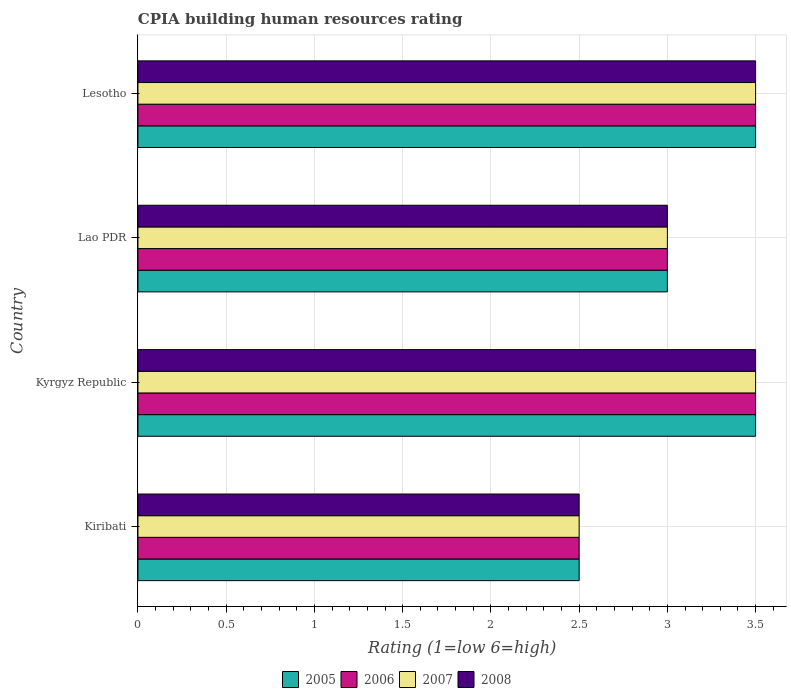How many different coloured bars are there?
Provide a succinct answer. 4. How many groups of bars are there?
Your answer should be very brief. 4. Are the number of bars on each tick of the Y-axis equal?
Your response must be concise. Yes. What is the label of the 3rd group of bars from the top?
Offer a terse response. Kyrgyz Republic. What is the CPIA rating in 2005 in Lesotho?
Your answer should be compact. 3.5. Across all countries, what is the minimum CPIA rating in 2005?
Provide a succinct answer. 2.5. In which country was the CPIA rating in 2008 maximum?
Provide a short and direct response. Kyrgyz Republic. In which country was the CPIA rating in 2005 minimum?
Your answer should be compact. Kiribati. What is the total CPIA rating in 2005 in the graph?
Your response must be concise. 12.5. What is the average CPIA rating in 2008 per country?
Ensure brevity in your answer.  3.12. What is the difference between the CPIA rating in 2008 and CPIA rating in 2006 in Lao PDR?
Your response must be concise. 0. In how many countries, is the CPIA rating in 2007 greater than 2.3 ?
Your response must be concise. 4. What is the ratio of the CPIA rating in 2008 in Kiribati to that in Lao PDR?
Offer a terse response. 0.83. Is the CPIA rating in 2006 in Lao PDR less than that in Lesotho?
Give a very brief answer. Yes. What is the difference between the highest and the second highest CPIA rating in 2005?
Your answer should be compact. 0. Is the sum of the CPIA rating in 2007 in Lao PDR and Lesotho greater than the maximum CPIA rating in 2008 across all countries?
Make the answer very short. Yes. What does the 4th bar from the top in Kiribati represents?
Offer a very short reply. 2005. What does the 2nd bar from the bottom in Lao PDR represents?
Provide a succinct answer. 2006. Is it the case that in every country, the sum of the CPIA rating in 2007 and CPIA rating in 2008 is greater than the CPIA rating in 2005?
Give a very brief answer. Yes. How many bars are there?
Provide a short and direct response. 16. Are all the bars in the graph horizontal?
Your answer should be compact. Yes. How many countries are there in the graph?
Make the answer very short. 4. Are the values on the major ticks of X-axis written in scientific E-notation?
Make the answer very short. No. Does the graph contain any zero values?
Provide a short and direct response. No. What is the title of the graph?
Make the answer very short. CPIA building human resources rating. Does "1966" appear as one of the legend labels in the graph?
Your response must be concise. No. What is the Rating (1=low 6=high) in 2008 in Kiribati?
Offer a very short reply. 2.5. What is the Rating (1=low 6=high) in 2005 in Kyrgyz Republic?
Make the answer very short. 3.5. What is the Rating (1=low 6=high) of 2007 in Kyrgyz Republic?
Offer a very short reply. 3.5. What is the Rating (1=low 6=high) in 2007 in Lao PDR?
Provide a succinct answer. 3. What is the Rating (1=low 6=high) in 2008 in Lao PDR?
Make the answer very short. 3. What is the Rating (1=low 6=high) of 2005 in Lesotho?
Ensure brevity in your answer.  3.5. What is the Rating (1=low 6=high) of 2007 in Lesotho?
Provide a short and direct response. 3.5. What is the Rating (1=low 6=high) in 2008 in Lesotho?
Give a very brief answer. 3.5. Across all countries, what is the maximum Rating (1=low 6=high) of 2008?
Provide a succinct answer. 3.5. What is the total Rating (1=low 6=high) in 2005 in the graph?
Provide a succinct answer. 12.5. What is the total Rating (1=low 6=high) of 2006 in the graph?
Give a very brief answer. 12.5. What is the total Rating (1=low 6=high) of 2007 in the graph?
Your answer should be very brief. 12.5. What is the difference between the Rating (1=low 6=high) in 2005 in Kiribati and that in Kyrgyz Republic?
Provide a succinct answer. -1. What is the difference between the Rating (1=low 6=high) of 2006 in Kiribati and that in Kyrgyz Republic?
Offer a very short reply. -1. What is the difference between the Rating (1=low 6=high) of 2005 in Kiribati and that in Lao PDR?
Offer a terse response. -0.5. What is the difference between the Rating (1=low 6=high) of 2006 in Kiribati and that in Lao PDR?
Make the answer very short. -0.5. What is the difference between the Rating (1=low 6=high) in 2007 in Kiribati and that in Lao PDR?
Keep it short and to the point. -0.5. What is the difference between the Rating (1=low 6=high) in 2006 in Kiribati and that in Lesotho?
Keep it short and to the point. -1. What is the difference between the Rating (1=low 6=high) of 2007 in Kiribati and that in Lesotho?
Your answer should be very brief. -1. What is the difference between the Rating (1=low 6=high) of 2008 in Kiribati and that in Lesotho?
Your answer should be compact. -1. What is the difference between the Rating (1=low 6=high) of 2005 in Kyrgyz Republic and that in Lao PDR?
Provide a short and direct response. 0.5. What is the difference between the Rating (1=low 6=high) of 2006 in Kyrgyz Republic and that in Lao PDR?
Your answer should be compact. 0.5. What is the difference between the Rating (1=low 6=high) of 2008 in Kyrgyz Republic and that in Lao PDR?
Your answer should be compact. 0.5. What is the difference between the Rating (1=low 6=high) in 2007 in Lao PDR and that in Lesotho?
Provide a short and direct response. -0.5. What is the difference between the Rating (1=low 6=high) in 2008 in Lao PDR and that in Lesotho?
Provide a succinct answer. -0.5. What is the difference between the Rating (1=low 6=high) of 2005 in Kiribati and the Rating (1=low 6=high) of 2006 in Kyrgyz Republic?
Your answer should be compact. -1. What is the difference between the Rating (1=low 6=high) of 2005 in Kiribati and the Rating (1=low 6=high) of 2007 in Kyrgyz Republic?
Offer a very short reply. -1. What is the difference between the Rating (1=low 6=high) in 2005 in Kiribati and the Rating (1=low 6=high) in 2008 in Kyrgyz Republic?
Ensure brevity in your answer.  -1. What is the difference between the Rating (1=low 6=high) of 2006 in Kiribati and the Rating (1=low 6=high) of 2008 in Kyrgyz Republic?
Offer a very short reply. -1. What is the difference between the Rating (1=low 6=high) of 2005 in Kiribati and the Rating (1=low 6=high) of 2006 in Lao PDR?
Keep it short and to the point. -0.5. What is the difference between the Rating (1=low 6=high) of 2006 in Kiribati and the Rating (1=low 6=high) of 2007 in Lao PDR?
Offer a terse response. -0.5. What is the difference between the Rating (1=low 6=high) in 2006 in Kiribati and the Rating (1=low 6=high) in 2008 in Lao PDR?
Ensure brevity in your answer.  -0.5. What is the difference between the Rating (1=low 6=high) of 2005 in Kiribati and the Rating (1=low 6=high) of 2006 in Lesotho?
Keep it short and to the point. -1. What is the difference between the Rating (1=low 6=high) in 2005 in Kiribati and the Rating (1=low 6=high) in 2007 in Lesotho?
Offer a very short reply. -1. What is the difference between the Rating (1=low 6=high) of 2006 in Kiribati and the Rating (1=low 6=high) of 2007 in Lesotho?
Your response must be concise. -1. What is the difference between the Rating (1=low 6=high) in 2007 in Kiribati and the Rating (1=low 6=high) in 2008 in Lesotho?
Offer a terse response. -1. What is the difference between the Rating (1=low 6=high) in 2005 in Kyrgyz Republic and the Rating (1=low 6=high) in 2006 in Lao PDR?
Offer a terse response. 0.5. What is the difference between the Rating (1=low 6=high) of 2006 in Kyrgyz Republic and the Rating (1=low 6=high) of 2007 in Lao PDR?
Give a very brief answer. 0.5. What is the difference between the Rating (1=low 6=high) in 2006 in Kyrgyz Republic and the Rating (1=low 6=high) in 2008 in Lao PDR?
Provide a short and direct response. 0.5. What is the difference between the Rating (1=low 6=high) in 2005 in Kyrgyz Republic and the Rating (1=low 6=high) in 2007 in Lesotho?
Provide a short and direct response. 0. What is the difference between the Rating (1=low 6=high) of 2006 in Kyrgyz Republic and the Rating (1=low 6=high) of 2008 in Lesotho?
Give a very brief answer. 0. What is the difference between the Rating (1=low 6=high) of 2005 in Lao PDR and the Rating (1=low 6=high) of 2008 in Lesotho?
Provide a succinct answer. -0.5. What is the difference between the Rating (1=low 6=high) in 2006 in Lao PDR and the Rating (1=low 6=high) in 2007 in Lesotho?
Give a very brief answer. -0.5. What is the difference between the Rating (1=low 6=high) of 2006 in Lao PDR and the Rating (1=low 6=high) of 2008 in Lesotho?
Offer a terse response. -0.5. What is the average Rating (1=low 6=high) of 2005 per country?
Your answer should be compact. 3.12. What is the average Rating (1=low 6=high) of 2006 per country?
Your answer should be very brief. 3.12. What is the average Rating (1=low 6=high) in 2007 per country?
Ensure brevity in your answer.  3.12. What is the average Rating (1=low 6=high) of 2008 per country?
Give a very brief answer. 3.12. What is the difference between the Rating (1=low 6=high) of 2005 and Rating (1=low 6=high) of 2006 in Kiribati?
Your answer should be very brief. 0. What is the difference between the Rating (1=low 6=high) in 2005 and Rating (1=low 6=high) in 2008 in Kiribati?
Your answer should be very brief. 0. What is the difference between the Rating (1=low 6=high) of 2006 and Rating (1=low 6=high) of 2007 in Kiribati?
Offer a very short reply. 0. What is the difference between the Rating (1=low 6=high) of 2006 and Rating (1=low 6=high) of 2008 in Kiribati?
Provide a succinct answer. 0. What is the difference between the Rating (1=low 6=high) of 2007 and Rating (1=low 6=high) of 2008 in Kiribati?
Give a very brief answer. 0. What is the difference between the Rating (1=low 6=high) in 2005 and Rating (1=low 6=high) in 2006 in Kyrgyz Republic?
Your response must be concise. 0. What is the difference between the Rating (1=low 6=high) of 2005 and Rating (1=low 6=high) of 2007 in Kyrgyz Republic?
Offer a very short reply. 0. What is the difference between the Rating (1=low 6=high) of 2006 and Rating (1=low 6=high) of 2007 in Kyrgyz Republic?
Your answer should be very brief. 0. What is the difference between the Rating (1=low 6=high) in 2007 and Rating (1=low 6=high) in 2008 in Kyrgyz Republic?
Give a very brief answer. 0. What is the difference between the Rating (1=low 6=high) of 2005 and Rating (1=low 6=high) of 2006 in Lao PDR?
Offer a very short reply. 0. What is the difference between the Rating (1=low 6=high) of 2005 and Rating (1=low 6=high) of 2008 in Lao PDR?
Your response must be concise. 0. What is the difference between the Rating (1=low 6=high) in 2006 and Rating (1=low 6=high) in 2007 in Lao PDR?
Give a very brief answer. 0. What is the difference between the Rating (1=low 6=high) in 2005 and Rating (1=low 6=high) in 2007 in Lesotho?
Offer a terse response. 0. What is the difference between the Rating (1=low 6=high) in 2006 and Rating (1=low 6=high) in 2007 in Lesotho?
Your answer should be compact. 0. What is the ratio of the Rating (1=low 6=high) in 2005 in Kiribati to that in Kyrgyz Republic?
Offer a very short reply. 0.71. What is the ratio of the Rating (1=low 6=high) of 2006 in Kiribati to that in Kyrgyz Republic?
Offer a terse response. 0.71. What is the ratio of the Rating (1=low 6=high) of 2007 in Kiribati to that in Kyrgyz Republic?
Make the answer very short. 0.71. What is the ratio of the Rating (1=low 6=high) of 2008 in Kiribati to that in Kyrgyz Republic?
Give a very brief answer. 0.71. What is the ratio of the Rating (1=low 6=high) of 2005 in Kiribati to that in Lao PDR?
Provide a succinct answer. 0.83. What is the ratio of the Rating (1=low 6=high) of 2006 in Kiribati to that in Lao PDR?
Your response must be concise. 0.83. What is the ratio of the Rating (1=low 6=high) in 2007 in Kiribati to that in Lao PDR?
Give a very brief answer. 0.83. What is the ratio of the Rating (1=low 6=high) in 2008 in Kiribati to that in Lao PDR?
Keep it short and to the point. 0.83. What is the ratio of the Rating (1=low 6=high) of 2006 in Kiribati to that in Lesotho?
Give a very brief answer. 0.71. What is the ratio of the Rating (1=low 6=high) of 2007 in Kiribati to that in Lesotho?
Your answer should be very brief. 0.71. What is the ratio of the Rating (1=low 6=high) of 2006 in Kyrgyz Republic to that in Lao PDR?
Your answer should be compact. 1.17. What is the ratio of the Rating (1=low 6=high) of 2008 in Kyrgyz Republic to that in Lao PDR?
Ensure brevity in your answer.  1.17. What is the ratio of the Rating (1=low 6=high) of 2005 in Kyrgyz Republic to that in Lesotho?
Your answer should be very brief. 1. What is the ratio of the Rating (1=low 6=high) in 2006 in Kyrgyz Republic to that in Lesotho?
Offer a very short reply. 1. What is the ratio of the Rating (1=low 6=high) in 2007 in Lao PDR to that in Lesotho?
Give a very brief answer. 0.86. What is the difference between the highest and the second highest Rating (1=low 6=high) in 2005?
Give a very brief answer. 0. What is the difference between the highest and the second highest Rating (1=low 6=high) of 2008?
Your answer should be compact. 0. What is the difference between the highest and the lowest Rating (1=low 6=high) of 2005?
Your response must be concise. 1. What is the difference between the highest and the lowest Rating (1=low 6=high) of 2007?
Give a very brief answer. 1. What is the difference between the highest and the lowest Rating (1=low 6=high) of 2008?
Your answer should be compact. 1. 